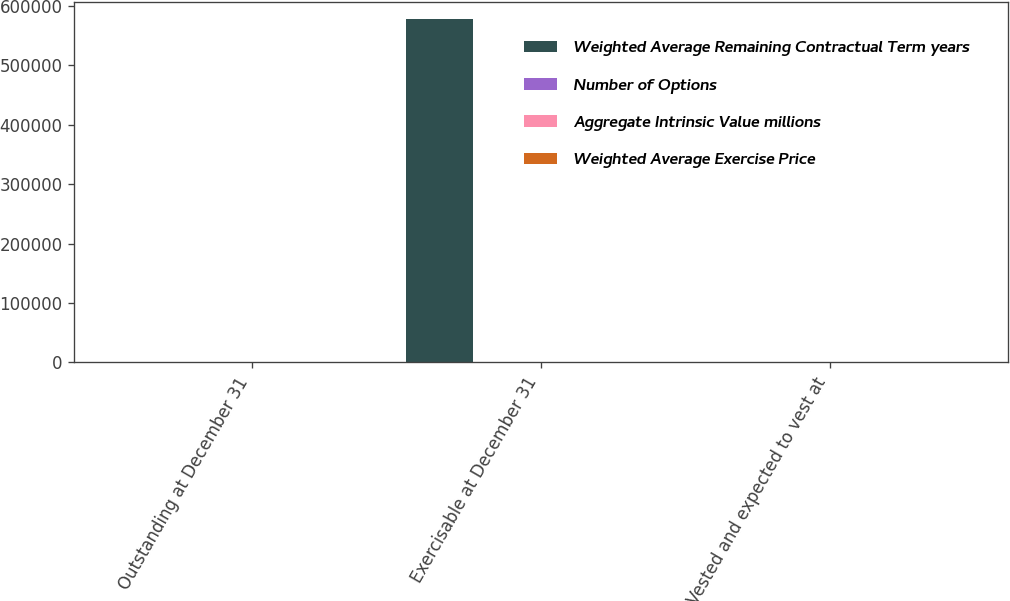Convert chart to OTSL. <chart><loc_0><loc_0><loc_500><loc_500><stacked_bar_chart><ecel><fcel>Outstanding at December 31<fcel>Exercisable at December 31<fcel>Vested and expected to vest at<nl><fcel>Weighted Average Remaining Contractual Term years<fcel>18.87<fcel>576963<fcel>18.87<nl><fcel>Number of Options<fcel>20.75<fcel>17<fcel>20.74<nl><fcel>Aggregate Intrinsic Value millions<fcel>8.3<fcel>7.2<fcel>8.3<nl><fcel>Weighted Average Exercise Price<fcel>34.9<fcel>10.5<fcel>34.3<nl></chart> 